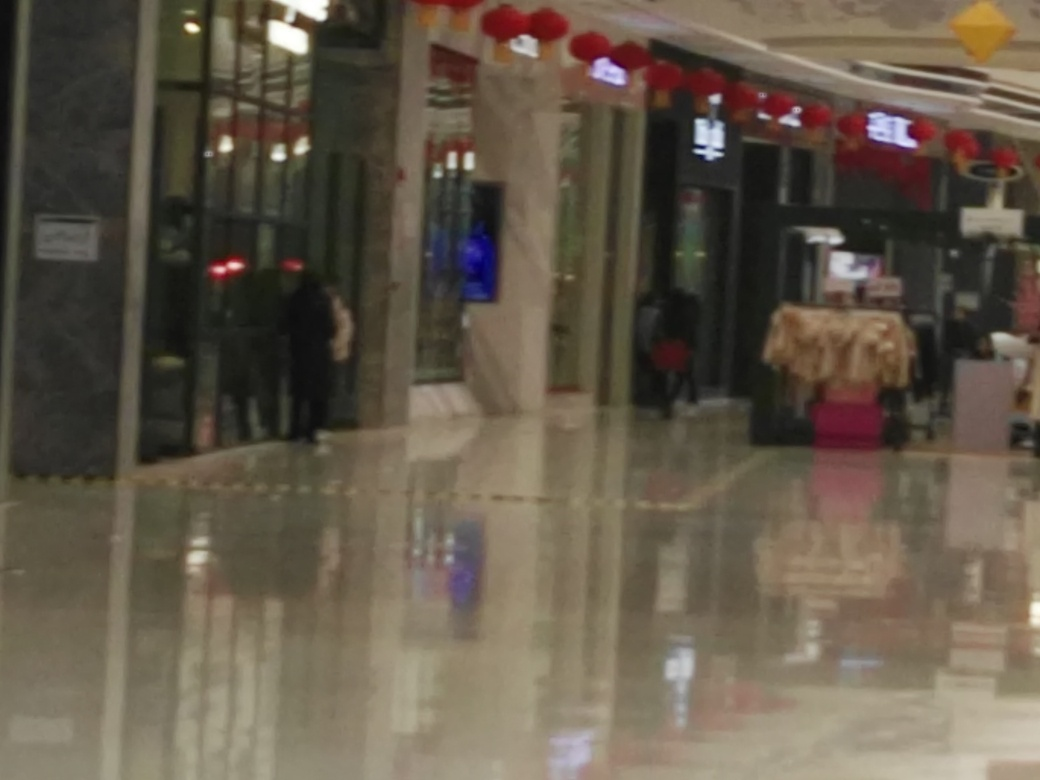What possible improvements could be made to this photo? To enhance the quality of this photo, one could take several steps. Primarily, adjusting the focus is crucial to ensure the subjects within the frame are sharp. Using a higher shutter speed could prevent motion blur if the blur is due to camera shake or movement. Furthermore, ensuring adequate lighting can help the camera focus better, while composing the shot to draw attention to key elements in the scene can make the photograph more engaging and aesthetically pleasing. 